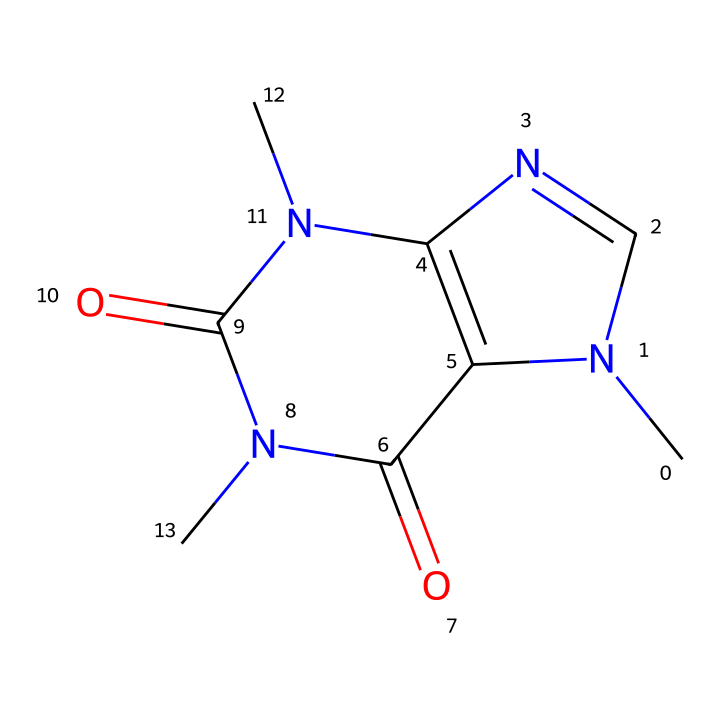What is the molecular formula of caffeine? To determine the molecular formula from the SMILES representation, we analyze the elements present: there are 8 carbon (C), 10 hydrogen (H), 4 nitrogen (N), and 2 oxygen (O) atoms. So, the molecular formula is C8H10N4O2.
Answer: C8H10N4O2 How many nitrogen atoms are present in caffeine? In the SMILES representation, we can identify 4 nitrogen (N) atoms in the structure.
Answer: 4 What type of bonding is present in the molecular structure of caffeine? The molecular structure includes both covalent bonds (between carbon, nitrogen, and oxygen) and intermolecular hydrogen bonding (due to the presence of nitrogen and oxygen).
Answer: covalent and hydrogen bonding What functional groups are present in caffeine? The structure shows carbonyl groups (C=O) and amine groups (–NH). Functional groups are identified mainly by their characteristic atoms and bonding arrangements.
Answer: carbonyl and amine groups Is caffeine a polar or nonpolar molecule? By examining the structure, caffeine has polar bonds (due to nitrogen and oxygen) but has a hydrophobic carbon framework, making it overall moderately polar.
Answer: moderately polar How many rings are present in the structure of caffeine? The SMILES indicates that there are two fused rings in caffeine, as evidenced by the "N1" and "C2=" indicating the start of ring structures.
Answer: 2 What is the primary role of caffeine in coffee? Caffeine acts as a central nervous system stimulant, which is evidenced by its alkaloid nature and physiological effects on humans.
Answer: stimulant 